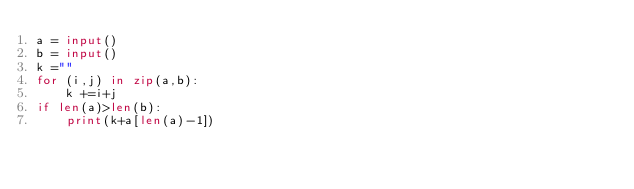Convert code to text. <code><loc_0><loc_0><loc_500><loc_500><_Python_>a = input()
b = input()
k =""
for (i,j) in zip(a,b):
    k +=i+j
if len(a)>len(b):
    print(k+a[len(a)-1])</code> 